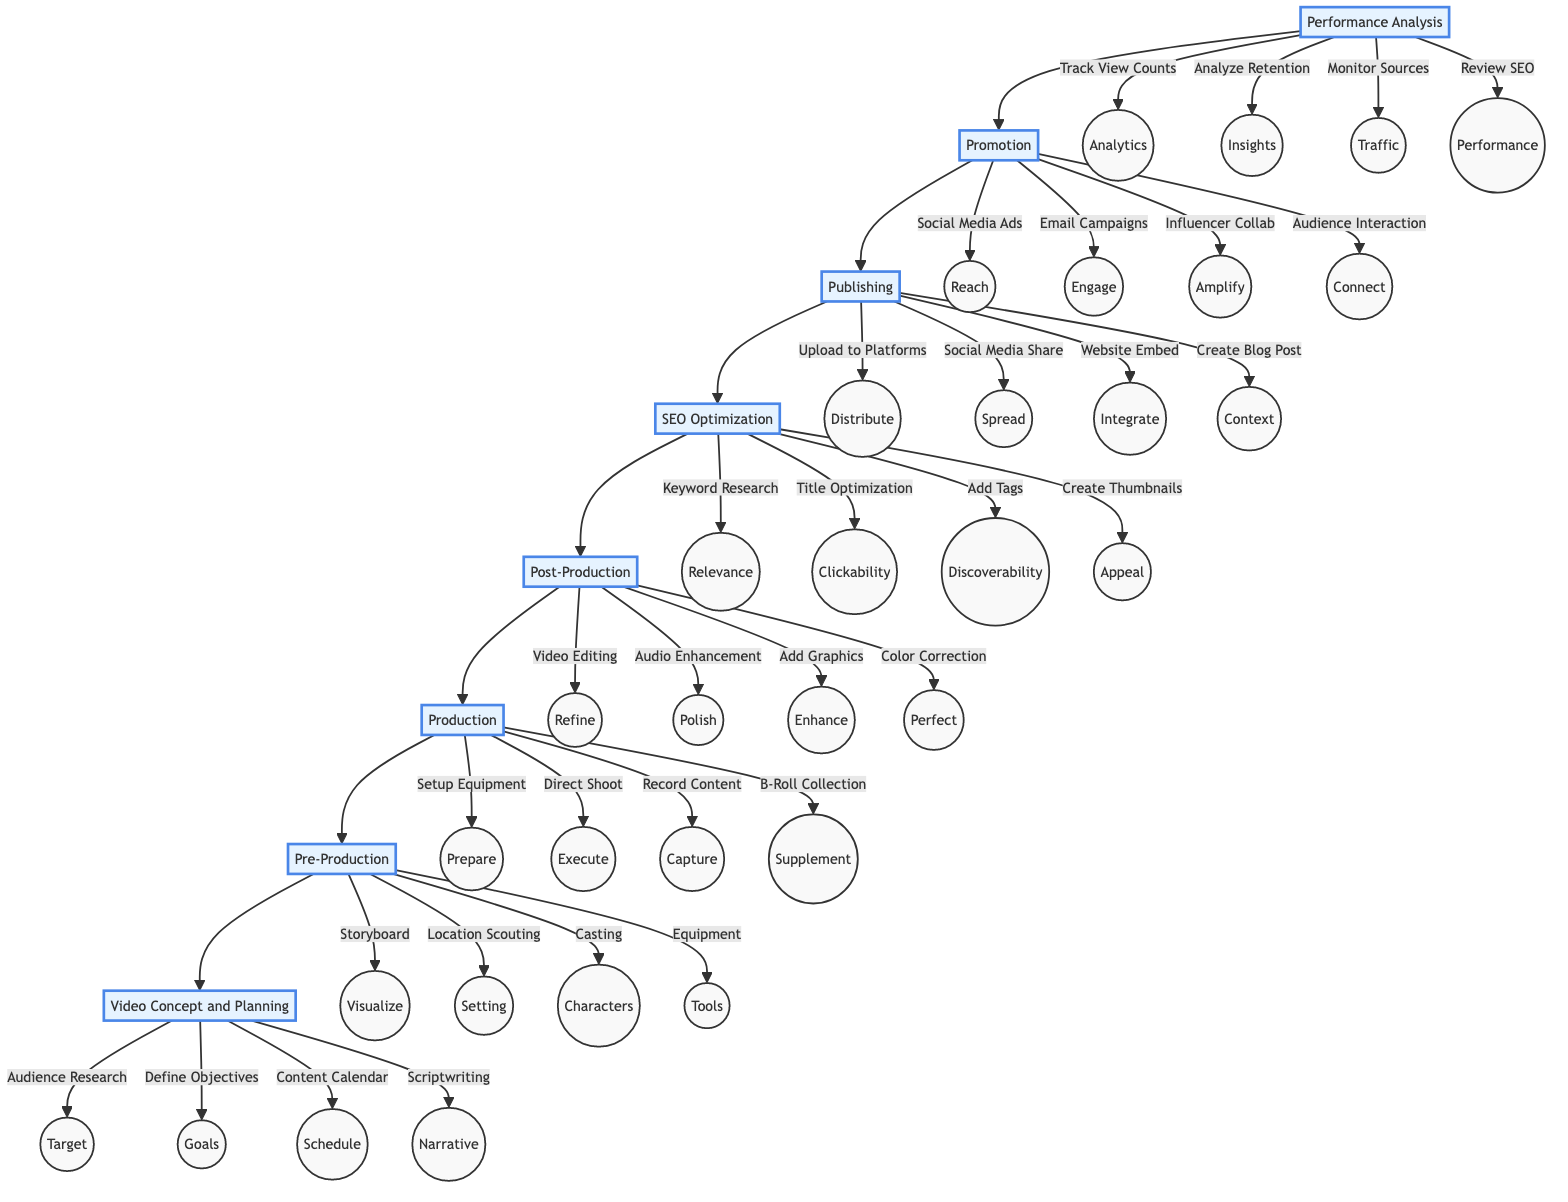What is the top stage in the diagram? The diagram shows "Performance Analysis" as the top stage, meaning it is the first step in the process.
Answer: Performance Analysis How many stages are in the diagram? By counting each labeled stage from "Performance Analysis" to "Video Concept and Planning," there are a total of 8 stages present in the flowchart.
Answer: 8 Which stage follows "Pre-Production"? The next stage after "Pre-Production" is "Production," indicating the logical flow in the content creation process.
Answer: Production What task is included in the "SEO Optimization" stage? "Keyword Research" is one of the tasks detailed within the "SEO Optimization" stage, highlighting its importance in video marketing.
Answer: Keyword Research What are the four tasks listed under the "Promotion" stage? The tasks are "Social Media Advertising," "Email Marketing Campaigns," "Collaboration with Influencers," and "Engage with Audience through Comments," providing a comprehensive approach to promoting the video content.
Answer: Social Media Advertising, Email Marketing Campaigns, Collaboration with Influencers, Engage with Audience through Comments Which stage has the task "Directing the Shoot"? The task "Directing the Shoot" is part of the "Production" stage, where content creators manage the actual filming process.
Answer: Production What stage requires "Scriptwriting"? "Scriptwriting" is a crucial element of the "Video Concept and Planning" stage, where the narrative framework of the video is established.
Answer: Video Concept and Planning Which stage appears immediately before "Publishing"? The stage that comes immediately before "Publishing" is "SEO Optimization," confirming its relevance to ensuring the content is optimized for search before distribution.
Answer: SEO Optimization How does "Publishing" relate to "Promotion"? "Publishing" leads to "Promotion," meaning once the video is distributed, the next step is to actively promote it to reach the intended audience.
Answer: Promotion 